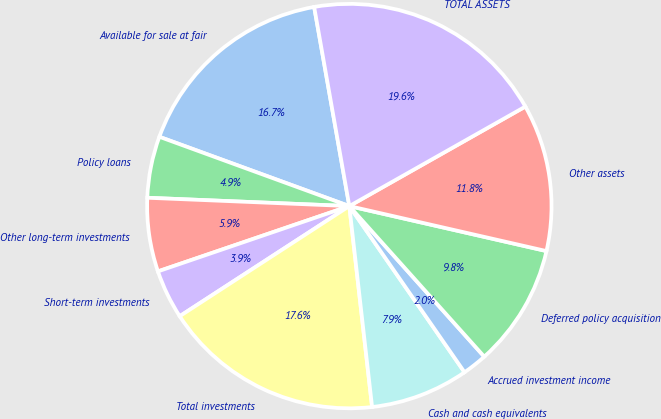<chart> <loc_0><loc_0><loc_500><loc_500><pie_chart><fcel>Available for sale at fair<fcel>Policy loans<fcel>Other long-term investments<fcel>Short-term investments<fcel>Total investments<fcel>Cash and cash equivalents<fcel>Accrued investment income<fcel>Deferred policy acquisition<fcel>Other assets<fcel>TOTAL ASSETS<nl><fcel>16.65%<fcel>4.91%<fcel>5.89%<fcel>3.93%<fcel>17.63%<fcel>7.85%<fcel>1.98%<fcel>9.8%<fcel>11.76%<fcel>19.59%<nl></chart> 